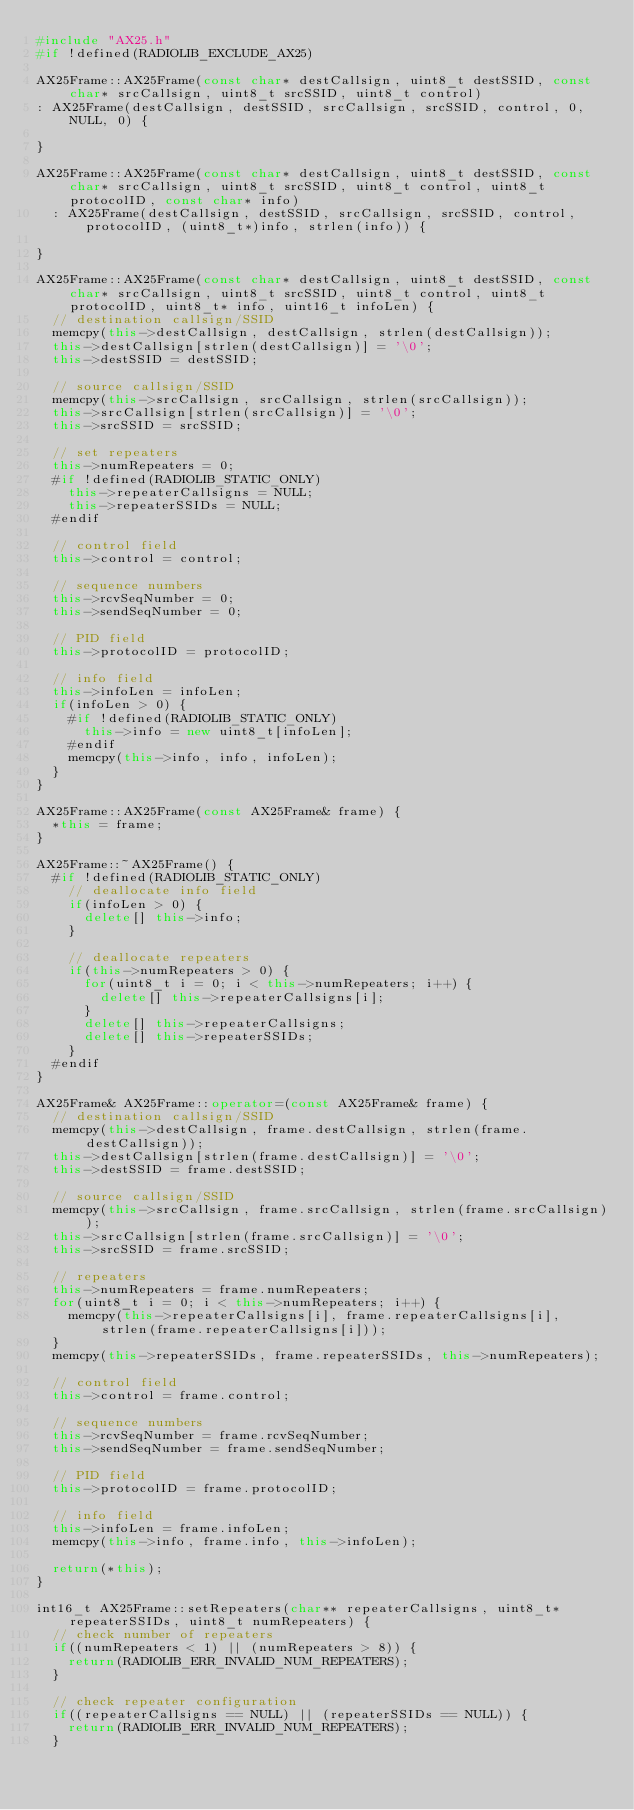<code> <loc_0><loc_0><loc_500><loc_500><_C++_>#include "AX25.h"
#if !defined(RADIOLIB_EXCLUDE_AX25)

AX25Frame::AX25Frame(const char* destCallsign, uint8_t destSSID, const char* srcCallsign, uint8_t srcSSID, uint8_t control)
: AX25Frame(destCallsign, destSSID, srcCallsign, srcSSID, control, 0, NULL, 0) {

}

AX25Frame::AX25Frame(const char* destCallsign, uint8_t destSSID, const char* srcCallsign, uint8_t srcSSID, uint8_t control, uint8_t protocolID, const char* info)
  : AX25Frame(destCallsign, destSSID, srcCallsign, srcSSID, control, protocolID, (uint8_t*)info, strlen(info)) {

}

AX25Frame::AX25Frame(const char* destCallsign, uint8_t destSSID, const char* srcCallsign, uint8_t srcSSID, uint8_t control, uint8_t protocolID, uint8_t* info, uint16_t infoLen) {
  // destination callsign/SSID
  memcpy(this->destCallsign, destCallsign, strlen(destCallsign));
  this->destCallsign[strlen(destCallsign)] = '\0';
  this->destSSID = destSSID;

  // source callsign/SSID
  memcpy(this->srcCallsign, srcCallsign, strlen(srcCallsign));
  this->srcCallsign[strlen(srcCallsign)] = '\0';
  this->srcSSID = srcSSID;

  // set repeaters
  this->numRepeaters = 0;
  #if !defined(RADIOLIB_STATIC_ONLY)
    this->repeaterCallsigns = NULL;
    this->repeaterSSIDs = NULL;
  #endif

  // control field
  this->control = control;

  // sequence numbers
  this->rcvSeqNumber = 0;
  this->sendSeqNumber = 0;

  // PID field
  this->protocolID = protocolID;

  // info field
  this->infoLen = infoLen;
  if(infoLen > 0) {
    #if !defined(RADIOLIB_STATIC_ONLY)
      this->info = new uint8_t[infoLen];
    #endif
    memcpy(this->info, info, infoLen);
  }
}

AX25Frame::AX25Frame(const AX25Frame& frame) {
  *this = frame;
}

AX25Frame::~AX25Frame() {
  #if !defined(RADIOLIB_STATIC_ONLY)
    // deallocate info field
    if(infoLen > 0) {
      delete[] this->info;
    }

    // deallocate repeaters
    if(this->numRepeaters > 0) {
      for(uint8_t i = 0; i < this->numRepeaters; i++) {
        delete[] this->repeaterCallsigns[i];
      }
      delete[] this->repeaterCallsigns;
      delete[] this->repeaterSSIDs;
    }
  #endif
}

AX25Frame& AX25Frame::operator=(const AX25Frame& frame) {
  // destination callsign/SSID
  memcpy(this->destCallsign, frame.destCallsign, strlen(frame.destCallsign));
  this->destCallsign[strlen(frame.destCallsign)] = '\0';
  this->destSSID = frame.destSSID;

  // source callsign/SSID
  memcpy(this->srcCallsign, frame.srcCallsign, strlen(frame.srcCallsign));
  this->srcCallsign[strlen(frame.srcCallsign)] = '\0';
  this->srcSSID = frame.srcSSID;

  // repeaters
  this->numRepeaters = frame.numRepeaters;
  for(uint8_t i = 0; i < this->numRepeaters; i++) {
    memcpy(this->repeaterCallsigns[i], frame.repeaterCallsigns[i], strlen(frame.repeaterCallsigns[i]));
  }
  memcpy(this->repeaterSSIDs, frame.repeaterSSIDs, this->numRepeaters);

  // control field
  this->control = frame.control;

  // sequence numbers
  this->rcvSeqNumber = frame.rcvSeqNumber;
  this->sendSeqNumber = frame.sendSeqNumber;

  // PID field
  this->protocolID = frame.protocolID;

  // info field
  this->infoLen = frame.infoLen;
  memcpy(this->info, frame.info, this->infoLen);

  return(*this);
}

int16_t AX25Frame::setRepeaters(char** repeaterCallsigns, uint8_t* repeaterSSIDs, uint8_t numRepeaters) {
  // check number of repeaters
  if((numRepeaters < 1) || (numRepeaters > 8)) {
    return(RADIOLIB_ERR_INVALID_NUM_REPEATERS);
  }

  // check repeater configuration
  if((repeaterCallsigns == NULL) || (repeaterSSIDs == NULL)) {
    return(RADIOLIB_ERR_INVALID_NUM_REPEATERS);
  }</code> 